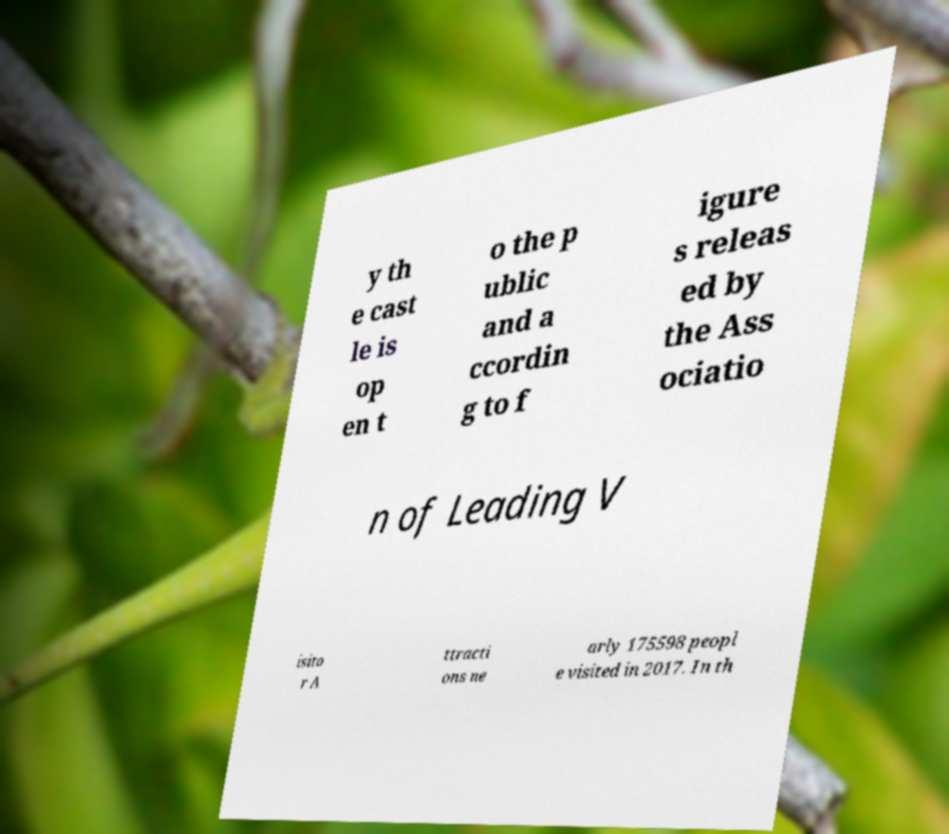Could you assist in decoding the text presented in this image and type it out clearly? y th e cast le is op en t o the p ublic and a ccordin g to f igure s releas ed by the Ass ociatio n of Leading V isito r A ttracti ons ne arly 175598 peopl e visited in 2017. In th 